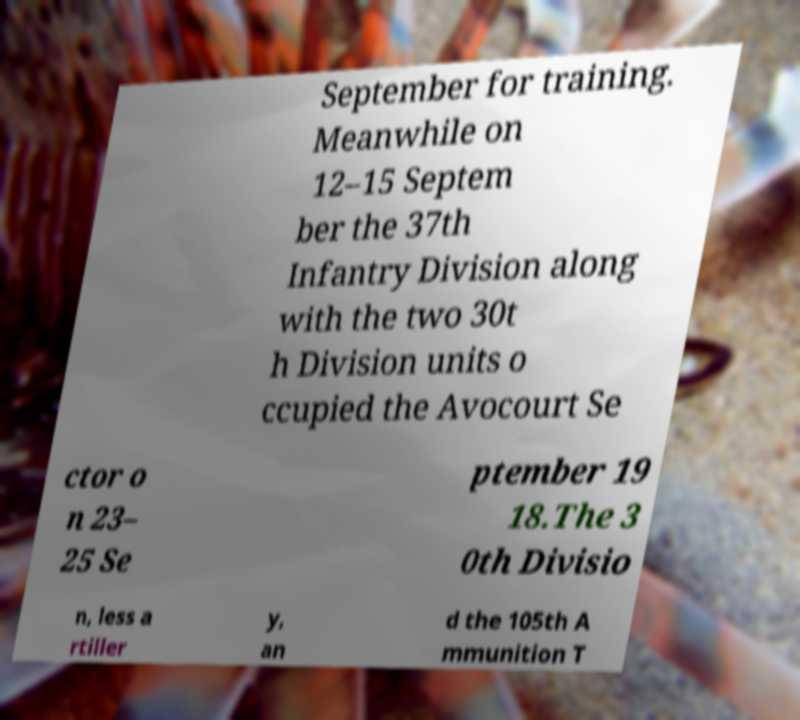There's text embedded in this image that I need extracted. Can you transcribe it verbatim? September for training. Meanwhile on 12–15 Septem ber the 37th Infantry Division along with the two 30t h Division units o ccupied the Avocourt Se ctor o n 23– 25 Se ptember 19 18.The 3 0th Divisio n, less a rtiller y, an d the 105th A mmunition T 